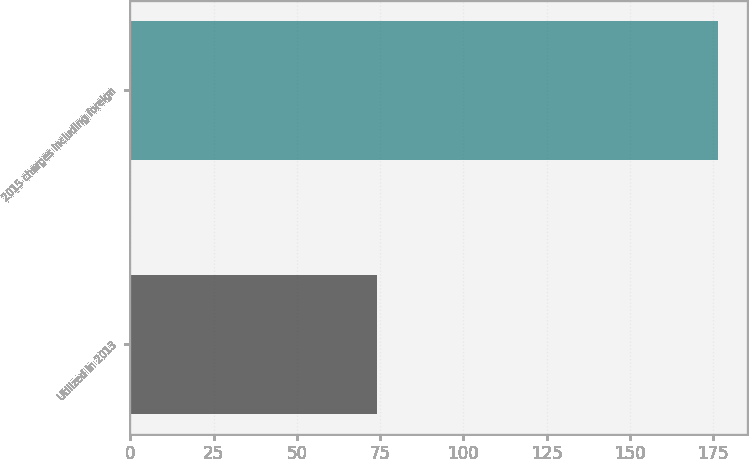Convert chart to OTSL. <chart><loc_0><loc_0><loc_500><loc_500><bar_chart><fcel>Utilized in 2013<fcel>2015 charges including foreign<nl><fcel>74.2<fcel>176.4<nl></chart> 